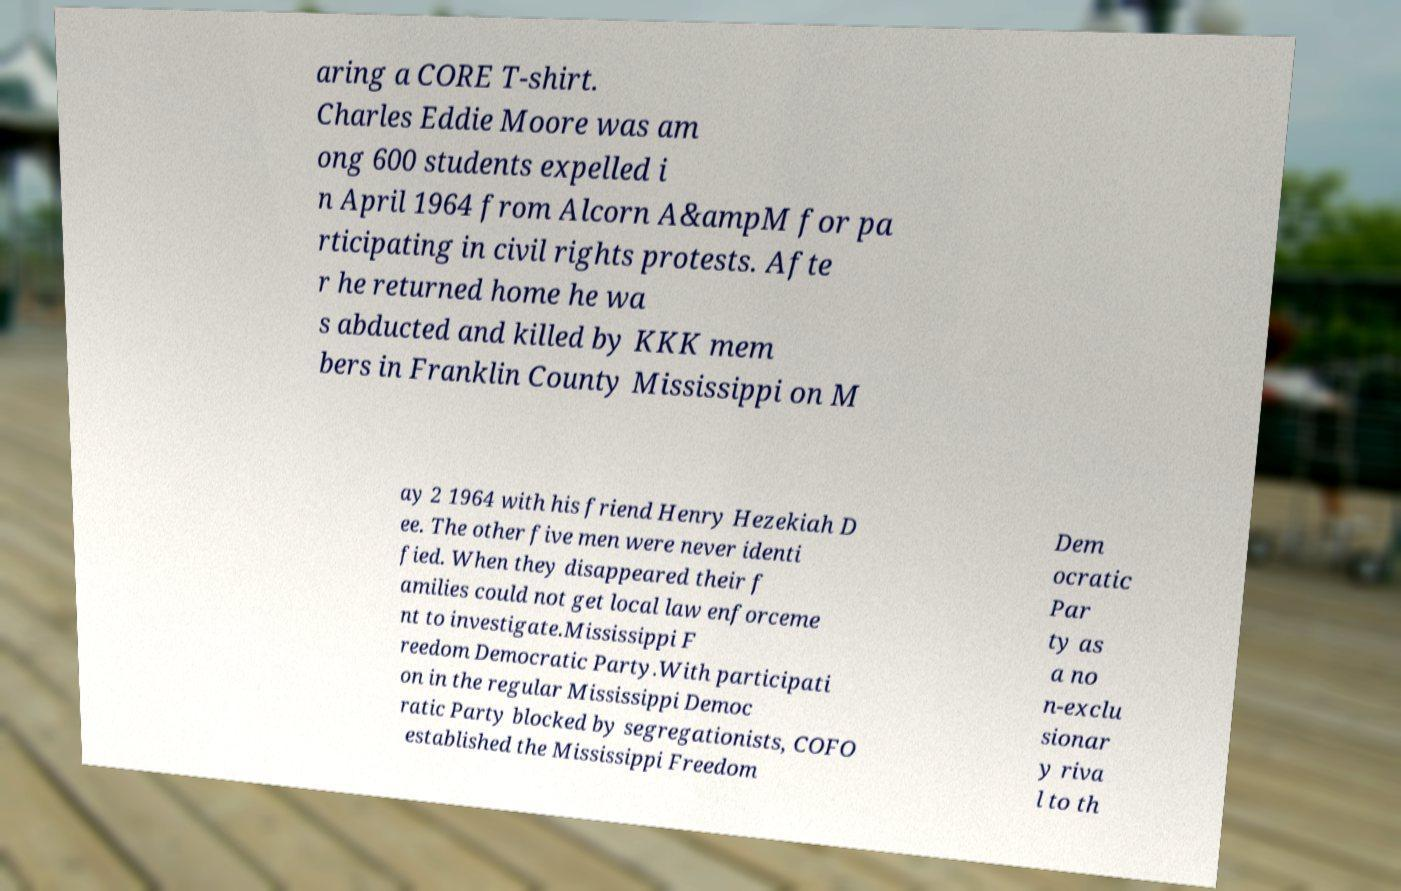There's text embedded in this image that I need extracted. Can you transcribe it verbatim? aring a CORE T-shirt. Charles Eddie Moore was am ong 600 students expelled i n April 1964 from Alcorn A&ampM for pa rticipating in civil rights protests. Afte r he returned home he wa s abducted and killed by KKK mem bers in Franklin County Mississippi on M ay 2 1964 with his friend Henry Hezekiah D ee. The other five men were never identi fied. When they disappeared their f amilies could not get local law enforceme nt to investigate.Mississippi F reedom Democratic Party.With participati on in the regular Mississippi Democ ratic Party blocked by segregationists, COFO established the Mississippi Freedom Dem ocratic Par ty as a no n-exclu sionar y riva l to th 